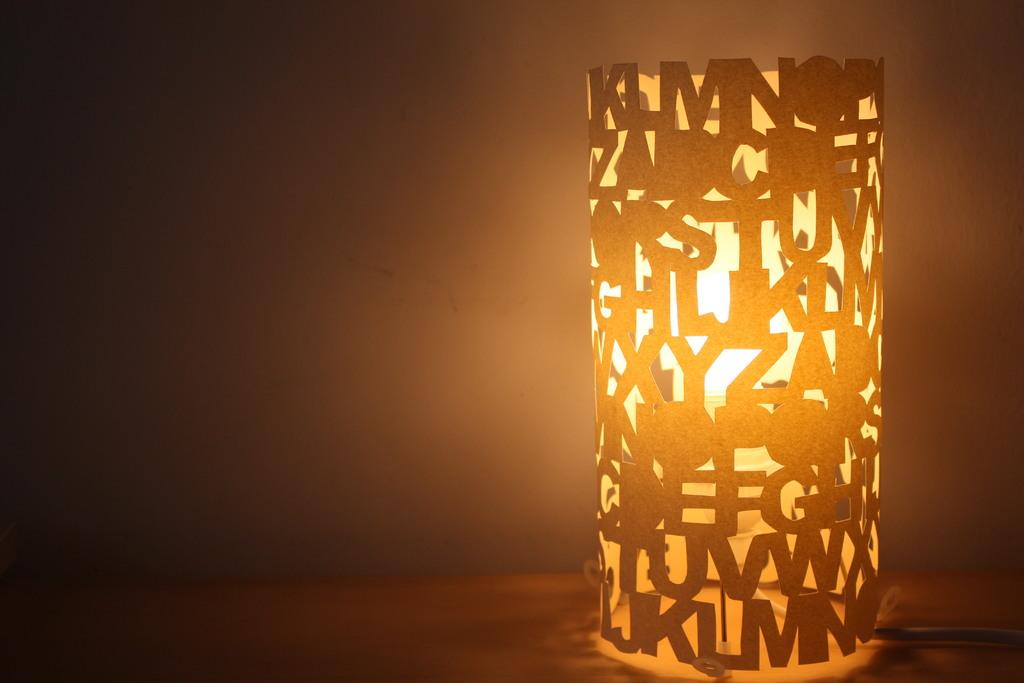What is present in the image that provides illumination? There is a light in the image. What is surrounding the light in the image? The light is surrounded by an art piece. What is unique about the art piece in the image? The art piece has alphabets shaped into it. Can you see a frog sitting on the light in the image? No, there is no frog present in the image. 